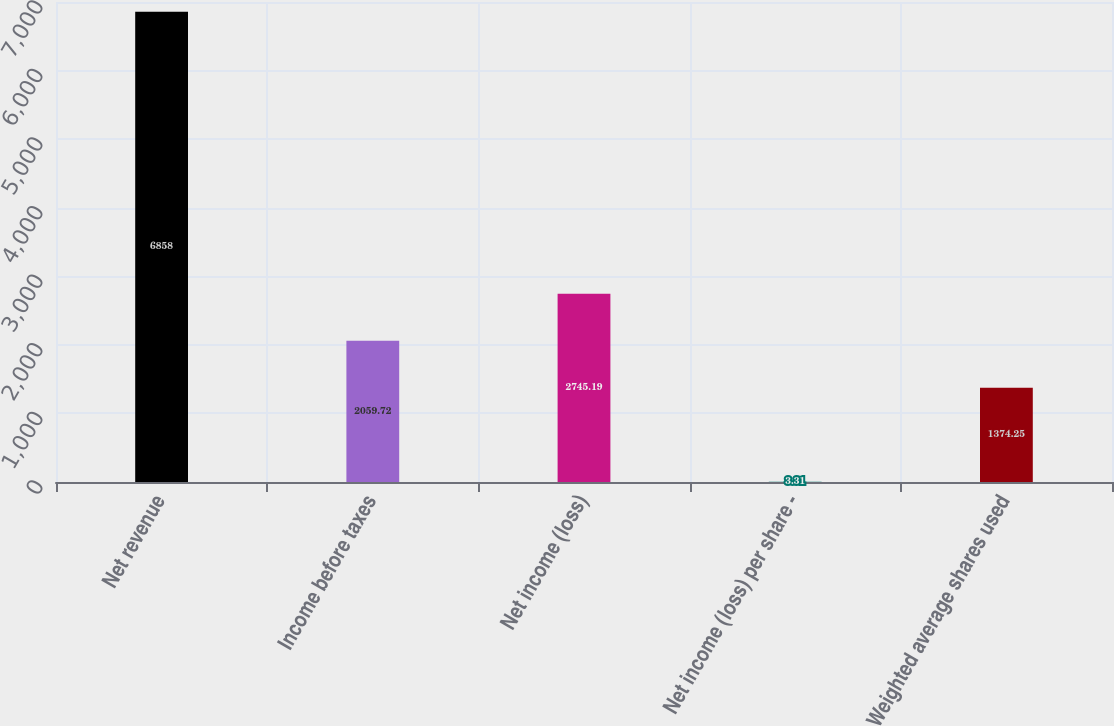<chart> <loc_0><loc_0><loc_500><loc_500><bar_chart><fcel>Net revenue<fcel>Income before taxes<fcel>Net income (loss)<fcel>Net income (loss) per share -<fcel>Weighted average shares used<nl><fcel>6858<fcel>2059.72<fcel>2745.19<fcel>3.31<fcel>1374.25<nl></chart> 